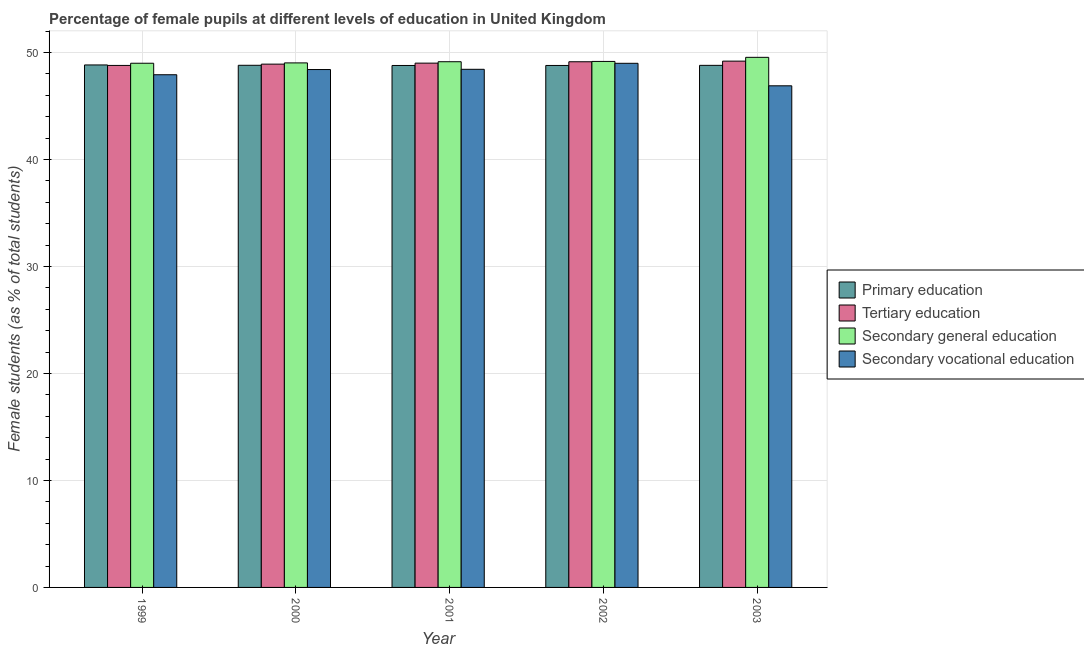Are the number of bars on each tick of the X-axis equal?
Your response must be concise. Yes. What is the percentage of female students in primary education in 2003?
Provide a succinct answer. 48.79. Across all years, what is the maximum percentage of female students in secondary education?
Give a very brief answer. 49.54. Across all years, what is the minimum percentage of female students in primary education?
Provide a succinct answer. 48.78. In which year was the percentage of female students in secondary vocational education minimum?
Offer a very short reply. 2003. What is the total percentage of female students in secondary education in the graph?
Keep it short and to the point. 245.84. What is the difference between the percentage of female students in tertiary education in 1999 and that in 2003?
Provide a short and direct response. -0.4. What is the difference between the percentage of female students in tertiary education in 2003 and the percentage of female students in primary education in 2000?
Make the answer very short. 0.28. What is the average percentage of female students in secondary education per year?
Your answer should be compact. 49.17. In the year 1999, what is the difference between the percentage of female students in secondary education and percentage of female students in secondary vocational education?
Provide a short and direct response. 0. In how many years, is the percentage of female students in tertiary education greater than 50 %?
Ensure brevity in your answer.  0. What is the ratio of the percentage of female students in secondary vocational education in 1999 to that in 2000?
Offer a terse response. 0.99. What is the difference between the highest and the second highest percentage of female students in primary education?
Make the answer very short. 0.03. What is the difference between the highest and the lowest percentage of female students in tertiary education?
Offer a terse response. 0.4. Is it the case that in every year, the sum of the percentage of female students in secondary education and percentage of female students in primary education is greater than the sum of percentage of female students in tertiary education and percentage of female students in secondary vocational education?
Provide a short and direct response. Yes. What does the 3rd bar from the left in 1999 represents?
Provide a short and direct response. Secondary general education. What does the 3rd bar from the right in 2002 represents?
Offer a very short reply. Tertiary education. How many bars are there?
Give a very brief answer. 20. Does the graph contain any zero values?
Your response must be concise. No. How many legend labels are there?
Ensure brevity in your answer.  4. How are the legend labels stacked?
Provide a succinct answer. Vertical. What is the title of the graph?
Offer a very short reply. Percentage of female pupils at different levels of education in United Kingdom. Does "Water" appear as one of the legend labels in the graph?
Offer a very short reply. No. What is the label or title of the X-axis?
Make the answer very short. Year. What is the label or title of the Y-axis?
Your answer should be compact. Female students (as % of total students). What is the Female students (as % of total students) in Primary education in 1999?
Ensure brevity in your answer.  48.83. What is the Female students (as % of total students) of Tertiary education in 1999?
Keep it short and to the point. 48.78. What is the Female students (as % of total students) of Secondary general education in 1999?
Your answer should be compact. 48.99. What is the Female students (as % of total students) in Secondary vocational education in 1999?
Provide a short and direct response. 47.91. What is the Female students (as % of total students) of Primary education in 2000?
Your answer should be compact. 48.8. What is the Female students (as % of total students) in Tertiary education in 2000?
Your response must be concise. 48.91. What is the Female students (as % of total students) of Secondary general education in 2000?
Ensure brevity in your answer.  49.02. What is the Female students (as % of total students) of Secondary vocational education in 2000?
Offer a very short reply. 48.4. What is the Female students (as % of total students) of Primary education in 2001?
Give a very brief answer. 48.78. What is the Female students (as % of total students) of Tertiary education in 2001?
Ensure brevity in your answer.  49. What is the Female students (as % of total students) of Secondary general education in 2001?
Keep it short and to the point. 49.13. What is the Female students (as % of total students) of Secondary vocational education in 2001?
Your answer should be very brief. 48.42. What is the Female students (as % of total students) of Primary education in 2002?
Your answer should be very brief. 48.78. What is the Female students (as % of total students) in Tertiary education in 2002?
Keep it short and to the point. 49.13. What is the Female students (as % of total students) of Secondary general education in 2002?
Provide a short and direct response. 49.16. What is the Female students (as % of total students) of Secondary vocational education in 2002?
Offer a terse response. 48.98. What is the Female students (as % of total students) of Primary education in 2003?
Offer a very short reply. 48.79. What is the Female students (as % of total students) in Tertiary education in 2003?
Ensure brevity in your answer.  49.19. What is the Female students (as % of total students) in Secondary general education in 2003?
Ensure brevity in your answer.  49.54. What is the Female students (as % of total students) in Secondary vocational education in 2003?
Give a very brief answer. 46.88. Across all years, what is the maximum Female students (as % of total students) in Primary education?
Provide a succinct answer. 48.83. Across all years, what is the maximum Female students (as % of total students) in Tertiary education?
Keep it short and to the point. 49.19. Across all years, what is the maximum Female students (as % of total students) of Secondary general education?
Provide a succinct answer. 49.54. Across all years, what is the maximum Female students (as % of total students) in Secondary vocational education?
Give a very brief answer. 48.98. Across all years, what is the minimum Female students (as % of total students) in Primary education?
Offer a terse response. 48.78. Across all years, what is the minimum Female students (as % of total students) of Tertiary education?
Ensure brevity in your answer.  48.78. Across all years, what is the minimum Female students (as % of total students) in Secondary general education?
Your answer should be compact. 48.99. Across all years, what is the minimum Female students (as % of total students) in Secondary vocational education?
Provide a succinct answer. 46.88. What is the total Female students (as % of total students) of Primary education in the graph?
Offer a very short reply. 243.98. What is the total Female students (as % of total students) of Tertiary education in the graph?
Offer a very short reply. 245.01. What is the total Female students (as % of total students) of Secondary general education in the graph?
Ensure brevity in your answer.  245.84. What is the total Female students (as % of total students) in Secondary vocational education in the graph?
Your answer should be compact. 240.61. What is the difference between the Female students (as % of total students) of Primary education in 1999 and that in 2000?
Your answer should be very brief. 0.03. What is the difference between the Female students (as % of total students) in Tertiary education in 1999 and that in 2000?
Offer a terse response. -0.12. What is the difference between the Female students (as % of total students) in Secondary general education in 1999 and that in 2000?
Ensure brevity in your answer.  -0.03. What is the difference between the Female students (as % of total students) in Secondary vocational education in 1999 and that in 2000?
Provide a short and direct response. -0.49. What is the difference between the Female students (as % of total students) of Primary education in 1999 and that in 2001?
Give a very brief answer. 0.05. What is the difference between the Female students (as % of total students) of Tertiary education in 1999 and that in 2001?
Provide a short and direct response. -0.22. What is the difference between the Female students (as % of total students) in Secondary general education in 1999 and that in 2001?
Provide a short and direct response. -0.14. What is the difference between the Female students (as % of total students) of Secondary vocational education in 1999 and that in 2001?
Offer a terse response. -0.51. What is the difference between the Female students (as % of total students) of Primary education in 1999 and that in 2002?
Provide a succinct answer. 0.05. What is the difference between the Female students (as % of total students) in Tertiary education in 1999 and that in 2002?
Ensure brevity in your answer.  -0.34. What is the difference between the Female students (as % of total students) in Secondary general education in 1999 and that in 2002?
Your answer should be very brief. -0.17. What is the difference between the Female students (as % of total students) of Secondary vocational education in 1999 and that in 2002?
Keep it short and to the point. -1.07. What is the difference between the Female students (as % of total students) in Primary education in 1999 and that in 2003?
Offer a terse response. 0.04. What is the difference between the Female students (as % of total students) in Tertiary education in 1999 and that in 2003?
Offer a very short reply. -0.4. What is the difference between the Female students (as % of total students) in Secondary general education in 1999 and that in 2003?
Provide a short and direct response. -0.55. What is the difference between the Female students (as % of total students) of Secondary vocational education in 1999 and that in 2003?
Your answer should be compact. 1.03. What is the difference between the Female students (as % of total students) in Primary education in 2000 and that in 2001?
Keep it short and to the point. 0.02. What is the difference between the Female students (as % of total students) in Tertiary education in 2000 and that in 2001?
Your response must be concise. -0.09. What is the difference between the Female students (as % of total students) of Secondary general education in 2000 and that in 2001?
Give a very brief answer. -0.11. What is the difference between the Female students (as % of total students) in Secondary vocational education in 2000 and that in 2001?
Give a very brief answer. -0.02. What is the difference between the Female students (as % of total students) in Primary education in 2000 and that in 2002?
Give a very brief answer. 0.02. What is the difference between the Female students (as % of total students) in Tertiary education in 2000 and that in 2002?
Your answer should be very brief. -0.22. What is the difference between the Female students (as % of total students) of Secondary general education in 2000 and that in 2002?
Your response must be concise. -0.14. What is the difference between the Female students (as % of total students) in Secondary vocational education in 2000 and that in 2002?
Your answer should be very brief. -0.58. What is the difference between the Female students (as % of total students) in Primary education in 2000 and that in 2003?
Make the answer very short. 0.01. What is the difference between the Female students (as % of total students) in Tertiary education in 2000 and that in 2003?
Your answer should be compact. -0.28. What is the difference between the Female students (as % of total students) in Secondary general education in 2000 and that in 2003?
Make the answer very short. -0.52. What is the difference between the Female students (as % of total students) in Secondary vocational education in 2000 and that in 2003?
Ensure brevity in your answer.  1.52. What is the difference between the Female students (as % of total students) in Primary education in 2001 and that in 2002?
Offer a very short reply. -0. What is the difference between the Female students (as % of total students) in Tertiary education in 2001 and that in 2002?
Keep it short and to the point. -0.13. What is the difference between the Female students (as % of total students) in Secondary general education in 2001 and that in 2002?
Your answer should be very brief. -0.03. What is the difference between the Female students (as % of total students) in Secondary vocational education in 2001 and that in 2002?
Keep it short and to the point. -0.56. What is the difference between the Female students (as % of total students) of Primary education in 2001 and that in 2003?
Make the answer very short. -0.01. What is the difference between the Female students (as % of total students) of Tertiary education in 2001 and that in 2003?
Offer a very short reply. -0.19. What is the difference between the Female students (as % of total students) in Secondary general education in 2001 and that in 2003?
Make the answer very short. -0.41. What is the difference between the Female students (as % of total students) in Secondary vocational education in 2001 and that in 2003?
Your answer should be compact. 1.54. What is the difference between the Female students (as % of total students) of Primary education in 2002 and that in 2003?
Give a very brief answer. -0.01. What is the difference between the Female students (as % of total students) in Tertiary education in 2002 and that in 2003?
Provide a succinct answer. -0.06. What is the difference between the Female students (as % of total students) in Secondary general education in 2002 and that in 2003?
Your response must be concise. -0.38. What is the difference between the Female students (as % of total students) of Secondary vocational education in 2002 and that in 2003?
Make the answer very short. 2.1. What is the difference between the Female students (as % of total students) in Primary education in 1999 and the Female students (as % of total students) in Tertiary education in 2000?
Give a very brief answer. -0.08. What is the difference between the Female students (as % of total students) in Primary education in 1999 and the Female students (as % of total students) in Secondary general education in 2000?
Provide a succinct answer. -0.19. What is the difference between the Female students (as % of total students) in Primary education in 1999 and the Female students (as % of total students) in Secondary vocational education in 2000?
Offer a terse response. 0.43. What is the difference between the Female students (as % of total students) of Tertiary education in 1999 and the Female students (as % of total students) of Secondary general education in 2000?
Provide a succinct answer. -0.24. What is the difference between the Female students (as % of total students) of Tertiary education in 1999 and the Female students (as % of total students) of Secondary vocational education in 2000?
Offer a very short reply. 0.38. What is the difference between the Female students (as % of total students) of Secondary general education in 1999 and the Female students (as % of total students) of Secondary vocational education in 2000?
Your answer should be very brief. 0.59. What is the difference between the Female students (as % of total students) of Primary education in 1999 and the Female students (as % of total students) of Tertiary education in 2001?
Provide a succinct answer. -0.17. What is the difference between the Female students (as % of total students) of Primary education in 1999 and the Female students (as % of total students) of Secondary general education in 2001?
Keep it short and to the point. -0.3. What is the difference between the Female students (as % of total students) in Primary education in 1999 and the Female students (as % of total students) in Secondary vocational education in 2001?
Offer a very short reply. 0.41. What is the difference between the Female students (as % of total students) in Tertiary education in 1999 and the Female students (as % of total students) in Secondary general education in 2001?
Make the answer very short. -0.35. What is the difference between the Female students (as % of total students) of Tertiary education in 1999 and the Female students (as % of total students) of Secondary vocational education in 2001?
Your answer should be very brief. 0.36. What is the difference between the Female students (as % of total students) of Secondary general education in 1999 and the Female students (as % of total students) of Secondary vocational education in 2001?
Provide a short and direct response. 0.57. What is the difference between the Female students (as % of total students) in Primary education in 1999 and the Female students (as % of total students) in Tertiary education in 2002?
Provide a succinct answer. -0.3. What is the difference between the Female students (as % of total students) in Primary education in 1999 and the Female students (as % of total students) in Secondary general education in 2002?
Give a very brief answer. -0.33. What is the difference between the Female students (as % of total students) of Primary education in 1999 and the Female students (as % of total students) of Secondary vocational education in 2002?
Provide a succinct answer. -0.15. What is the difference between the Female students (as % of total students) of Tertiary education in 1999 and the Female students (as % of total students) of Secondary general education in 2002?
Provide a short and direct response. -0.37. What is the difference between the Female students (as % of total students) in Tertiary education in 1999 and the Female students (as % of total students) in Secondary vocational education in 2002?
Provide a short and direct response. -0.2. What is the difference between the Female students (as % of total students) in Secondary general education in 1999 and the Female students (as % of total students) in Secondary vocational education in 2002?
Your response must be concise. 0.01. What is the difference between the Female students (as % of total students) in Primary education in 1999 and the Female students (as % of total students) in Tertiary education in 2003?
Keep it short and to the point. -0.36. What is the difference between the Female students (as % of total students) in Primary education in 1999 and the Female students (as % of total students) in Secondary general education in 2003?
Your answer should be compact. -0.71. What is the difference between the Female students (as % of total students) in Primary education in 1999 and the Female students (as % of total students) in Secondary vocational education in 2003?
Your answer should be very brief. 1.95. What is the difference between the Female students (as % of total students) in Tertiary education in 1999 and the Female students (as % of total students) in Secondary general education in 2003?
Give a very brief answer. -0.76. What is the difference between the Female students (as % of total students) in Tertiary education in 1999 and the Female students (as % of total students) in Secondary vocational education in 2003?
Offer a terse response. 1.9. What is the difference between the Female students (as % of total students) of Secondary general education in 1999 and the Female students (as % of total students) of Secondary vocational education in 2003?
Your answer should be compact. 2.11. What is the difference between the Female students (as % of total students) in Primary education in 2000 and the Female students (as % of total students) in Tertiary education in 2001?
Your answer should be very brief. -0.2. What is the difference between the Female students (as % of total students) of Primary education in 2000 and the Female students (as % of total students) of Secondary general education in 2001?
Provide a short and direct response. -0.33. What is the difference between the Female students (as % of total students) of Primary education in 2000 and the Female students (as % of total students) of Secondary vocational education in 2001?
Offer a very short reply. 0.37. What is the difference between the Female students (as % of total students) in Tertiary education in 2000 and the Female students (as % of total students) in Secondary general education in 2001?
Provide a short and direct response. -0.22. What is the difference between the Female students (as % of total students) in Tertiary education in 2000 and the Female students (as % of total students) in Secondary vocational education in 2001?
Ensure brevity in your answer.  0.48. What is the difference between the Female students (as % of total students) of Secondary general education in 2000 and the Female students (as % of total students) of Secondary vocational education in 2001?
Give a very brief answer. 0.6. What is the difference between the Female students (as % of total students) in Primary education in 2000 and the Female students (as % of total students) in Tertiary education in 2002?
Keep it short and to the point. -0.33. What is the difference between the Female students (as % of total students) of Primary education in 2000 and the Female students (as % of total students) of Secondary general education in 2002?
Your answer should be very brief. -0.36. What is the difference between the Female students (as % of total students) in Primary education in 2000 and the Female students (as % of total students) in Secondary vocational education in 2002?
Give a very brief answer. -0.19. What is the difference between the Female students (as % of total students) of Tertiary education in 2000 and the Female students (as % of total students) of Secondary general education in 2002?
Provide a succinct answer. -0.25. What is the difference between the Female students (as % of total students) in Tertiary education in 2000 and the Female students (as % of total students) in Secondary vocational education in 2002?
Keep it short and to the point. -0.08. What is the difference between the Female students (as % of total students) in Secondary general education in 2000 and the Female students (as % of total students) in Secondary vocational education in 2002?
Offer a terse response. 0.04. What is the difference between the Female students (as % of total students) of Primary education in 2000 and the Female students (as % of total students) of Tertiary education in 2003?
Offer a terse response. -0.39. What is the difference between the Female students (as % of total students) of Primary education in 2000 and the Female students (as % of total students) of Secondary general education in 2003?
Offer a very short reply. -0.74. What is the difference between the Female students (as % of total students) of Primary education in 2000 and the Female students (as % of total students) of Secondary vocational education in 2003?
Offer a terse response. 1.92. What is the difference between the Female students (as % of total students) in Tertiary education in 2000 and the Female students (as % of total students) in Secondary general education in 2003?
Provide a short and direct response. -0.64. What is the difference between the Female students (as % of total students) in Tertiary education in 2000 and the Female students (as % of total students) in Secondary vocational education in 2003?
Provide a succinct answer. 2.03. What is the difference between the Female students (as % of total students) of Secondary general education in 2000 and the Female students (as % of total students) of Secondary vocational education in 2003?
Provide a short and direct response. 2.14. What is the difference between the Female students (as % of total students) of Primary education in 2001 and the Female students (as % of total students) of Tertiary education in 2002?
Give a very brief answer. -0.35. What is the difference between the Female students (as % of total students) of Primary education in 2001 and the Female students (as % of total students) of Secondary general education in 2002?
Provide a short and direct response. -0.38. What is the difference between the Female students (as % of total students) of Primary education in 2001 and the Female students (as % of total students) of Secondary vocational education in 2002?
Provide a succinct answer. -0.2. What is the difference between the Female students (as % of total students) in Tertiary education in 2001 and the Female students (as % of total students) in Secondary general education in 2002?
Give a very brief answer. -0.16. What is the difference between the Female students (as % of total students) of Tertiary education in 2001 and the Female students (as % of total students) of Secondary vocational education in 2002?
Give a very brief answer. 0.02. What is the difference between the Female students (as % of total students) of Secondary general education in 2001 and the Female students (as % of total students) of Secondary vocational education in 2002?
Provide a short and direct response. 0.15. What is the difference between the Female students (as % of total students) of Primary education in 2001 and the Female students (as % of total students) of Tertiary education in 2003?
Your response must be concise. -0.41. What is the difference between the Female students (as % of total students) of Primary education in 2001 and the Female students (as % of total students) of Secondary general education in 2003?
Provide a short and direct response. -0.76. What is the difference between the Female students (as % of total students) of Primary education in 2001 and the Female students (as % of total students) of Secondary vocational education in 2003?
Ensure brevity in your answer.  1.9. What is the difference between the Female students (as % of total students) of Tertiary education in 2001 and the Female students (as % of total students) of Secondary general education in 2003?
Offer a very short reply. -0.54. What is the difference between the Female students (as % of total students) in Tertiary education in 2001 and the Female students (as % of total students) in Secondary vocational education in 2003?
Your answer should be compact. 2.12. What is the difference between the Female students (as % of total students) of Secondary general education in 2001 and the Female students (as % of total students) of Secondary vocational education in 2003?
Keep it short and to the point. 2.25. What is the difference between the Female students (as % of total students) in Primary education in 2002 and the Female students (as % of total students) in Tertiary education in 2003?
Provide a short and direct response. -0.41. What is the difference between the Female students (as % of total students) in Primary education in 2002 and the Female students (as % of total students) in Secondary general education in 2003?
Keep it short and to the point. -0.76. What is the difference between the Female students (as % of total students) in Primary education in 2002 and the Female students (as % of total students) in Secondary vocational education in 2003?
Keep it short and to the point. 1.9. What is the difference between the Female students (as % of total students) in Tertiary education in 2002 and the Female students (as % of total students) in Secondary general education in 2003?
Offer a terse response. -0.41. What is the difference between the Female students (as % of total students) in Tertiary education in 2002 and the Female students (as % of total students) in Secondary vocational education in 2003?
Provide a succinct answer. 2.25. What is the difference between the Female students (as % of total students) in Secondary general education in 2002 and the Female students (as % of total students) in Secondary vocational education in 2003?
Make the answer very short. 2.28. What is the average Female students (as % of total students) in Primary education per year?
Offer a very short reply. 48.8. What is the average Female students (as % of total students) in Tertiary education per year?
Provide a succinct answer. 49. What is the average Female students (as % of total students) in Secondary general education per year?
Offer a terse response. 49.17. What is the average Female students (as % of total students) in Secondary vocational education per year?
Ensure brevity in your answer.  48.12. In the year 1999, what is the difference between the Female students (as % of total students) of Primary education and Female students (as % of total students) of Tertiary education?
Offer a terse response. 0.05. In the year 1999, what is the difference between the Female students (as % of total students) in Primary education and Female students (as % of total students) in Secondary general education?
Offer a very short reply. -0.16. In the year 1999, what is the difference between the Female students (as % of total students) of Primary education and Female students (as % of total students) of Secondary vocational education?
Provide a succinct answer. 0.92. In the year 1999, what is the difference between the Female students (as % of total students) of Tertiary education and Female students (as % of total students) of Secondary general education?
Ensure brevity in your answer.  -0.2. In the year 1999, what is the difference between the Female students (as % of total students) of Tertiary education and Female students (as % of total students) of Secondary vocational education?
Your answer should be compact. 0.87. In the year 1999, what is the difference between the Female students (as % of total students) of Secondary general education and Female students (as % of total students) of Secondary vocational education?
Give a very brief answer. 1.07. In the year 2000, what is the difference between the Female students (as % of total students) in Primary education and Female students (as % of total students) in Tertiary education?
Your response must be concise. -0.11. In the year 2000, what is the difference between the Female students (as % of total students) in Primary education and Female students (as % of total students) in Secondary general education?
Provide a short and direct response. -0.22. In the year 2000, what is the difference between the Female students (as % of total students) in Primary education and Female students (as % of total students) in Secondary vocational education?
Your answer should be compact. 0.4. In the year 2000, what is the difference between the Female students (as % of total students) of Tertiary education and Female students (as % of total students) of Secondary general education?
Give a very brief answer. -0.11. In the year 2000, what is the difference between the Female students (as % of total students) in Tertiary education and Female students (as % of total students) in Secondary vocational education?
Provide a short and direct response. 0.5. In the year 2000, what is the difference between the Female students (as % of total students) of Secondary general education and Female students (as % of total students) of Secondary vocational education?
Offer a very short reply. 0.62. In the year 2001, what is the difference between the Female students (as % of total students) of Primary education and Female students (as % of total students) of Tertiary education?
Offer a terse response. -0.22. In the year 2001, what is the difference between the Female students (as % of total students) of Primary education and Female students (as % of total students) of Secondary general education?
Keep it short and to the point. -0.35. In the year 2001, what is the difference between the Female students (as % of total students) in Primary education and Female students (as % of total students) in Secondary vocational education?
Your answer should be compact. 0.36. In the year 2001, what is the difference between the Female students (as % of total students) in Tertiary education and Female students (as % of total students) in Secondary general education?
Offer a terse response. -0.13. In the year 2001, what is the difference between the Female students (as % of total students) of Tertiary education and Female students (as % of total students) of Secondary vocational education?
Offer a very short reply. 0.58. In the year 2001, what is the difference between the Female students (as % of total students) of Secondary general education and Female students (as % of total students) of Secondary vocational education?
Give a very brief answer. 0.71. In the year 2002, what is the difference between the Female students (as % of total students) of Primary education and Female students (as % of total students) of Tertiary education?
Provide a short and direct response. -0.35. In the year 2002, what is the difference between the Female students (as % of total students) in Primary education and Female students (as % of total students) in Secondary general education?
Your answer should be compact. -0.38. In the year 2002, what is the difference between the Female students (as % of total students) in Primary education and Female students (as % of total students) in Secondary vocational education?
Offer a terse response. -0.2. In the year 2002, what is the difference between the Female students (as % of total students) in Tertiary education and Female students (as % of total students) in Secondary general education?
Give a very brief answer. -0.03. In the year 2002, what is the difference between the Female students (as % of total students) in Tertiary education and Female students (as % of total students) in Secondary vocational education?
Your response must be concise. 0.15. In the year 2002, what is the difference between the Female students (as % of total students) of Secondary general education and Female students (as % of total students) of Secondary vocational education?
Offer a terse response. 0.18. In the year 2003, what is the difference between the Female students (as % of total students) in Primary education and Female students (as % of total students) in Tertiary education?
Provide a short and direct response. -0.39. In the year 2003, what is the difference between the Female students (as % of total students) in Primary education and Female students (as % of total students) in Secondary general education?
Provide a succinct answer. -0.75. In the year 2003, what is the difference between the Female students (as % of total students) of Primary education and Female students (as % of total students) of Secondary vocational education?
Provide a succinct answer. 1.91. In the year 2003, what is the difference between the Female students (as % of total students) of Tertiary education and Female students (as % of total students) of Secondary general education?
Your response must be concise. -0.36. In the year 2003, what is the difference between the Female students (as % of total students) of Tertiary education and Female students (as % of total students) of Secondary vocational education?
Give a very brief answer. 2.31. In the year 2003, what is the difference between the Female students (as % of total students) of Secondary general education and Female students (as % of total students) of Secondary vocational education?
Your response must be concise. 2.66. What is the ratio of the Female students (as % of total students) in Primary education in 1999 to that in 2001?
Offer a terse response. 1. What is the ratio of the Female students (as % of total students) of Primary education in 1999 to that in 2002?
Offer a very short reply. 1. What is the ratio of the Female students (as % of total students) in Secondary vocational education in 1999 to that in 2002?
Keep it short and to the point. 0.98. What is the ratio of the Female students (as % of total students) in Primary education in 2000 to that in 2001?
Your answer should be very brief. 1. What is the ratio of the Female students (as % of total students) in Secondary general education in 2000 to that in 2001?
Keep it short and to the point. 1. What is the ratio of the Female students (as % of total students) of Primary education in 2000 to that in 2002?
Your answer should be very brief. 1. What is the ratio of the Female students (as % of total students) in Tertiary education in 2000 to that in 2002?
Your response must be concise. 1. What is the ratio of the Female students (as % of total students) in Secondary general education in 2000 to that in 2002?
Offer a very short reply. 1. What is the ratio of the Female students (as % of total students) in Secondary vocational education in 2000 to that in 2002?
Your answer should be very brief. 0.99. What is the ratio of the Female students (as % of total students) of Tertiary education in 2000 to that in 2003?
Your answer should be very brief. 0.99. What is the ratio of the Female students (as % of total students) in Secondary vocational education in 2000 to that in 2003?
Give a very brief answer. 1.03. What is the ratio of the Female students (as % of total students) in Primary education in 2001 to that in 2002?
Provide a succinct answer. 1. What is the ratio of the Female students (as % of total students) in Secondary vocational education in 2001 to that in 2002?
Provide a short and direct response. 0.99. What is the ratio of the Female students (as % of total students) of Primary education in 2001 to that in 2003?
Your answer should be compact. 1. What is the ratio of the Female students (as % of total students) of Tertiary education in 2001 to that in 2003?
Provide a short and direct response. 1. What is the ratio of the Female students (as % of total students) in Secondary vocational education in 2001 to that in 2003?
Give a very brief answer. 1.03. What is the ratio of the Female students (as % of total students) of Primary education in 2002 to that in 2003?
Offer a terse response. 1. What is the ratio of the Female students (as % of total students) in Secondary general education in 2002 to that in 2003?
Your answer should be very brief. 0.99. What is the ratio of the Female students (as % of total students) in Secondary vocational education in 2002 to that in 2003?
Keep it short and to the point. 1.04. What is the difference between the highest and the second highest Female students (as % of total students) in Primary education?
Provide a short and direct response. 0.03. What is the difference between the highest and the second highest Female students (as % of total students) in Tertiary education?
Offer a terse response. 0.06. What is the difference between the highest and the second highest Female students (as % of total students) in Secondary general education?
Keep it short and to the point. 0.38. What is the difference between the highest and the second highest Female students (as % of total students) of Secondary vocational education?
Provide a short and direct response. 0.56. What is the difference between the highest and the lowest Female students (as % of total students) in Primary education?
Your answer should be very brief. 0.05. What is the difference between the highest and the lowest Female students (as % of total students) in Tertiary education?
Provide a short and direct response. 0.4. What is the difference between the highest and the lowest Female students (as % of total students) in Secondary general education?
Give a very brief answer. 0.55. What is the difference between the highest and the lowest Female students (as % of total students) in Secondary vocational education?
Your answer should be very brief. 2.1. 